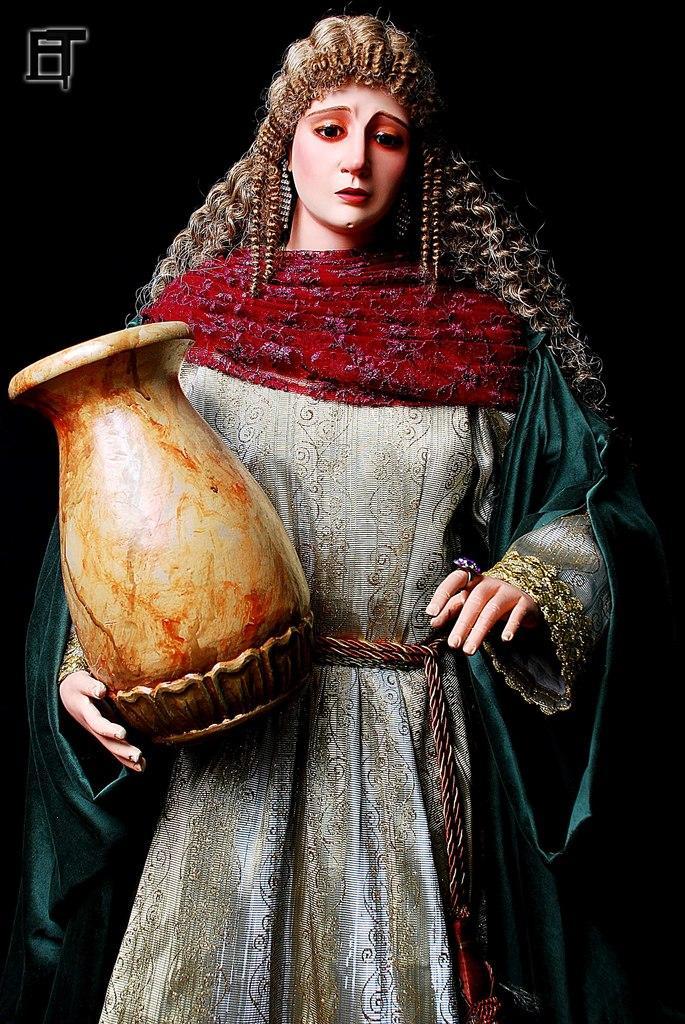How would you summarize this image in a sentence or two? In this picture we can see a woman, she is holding a pot and in the background we can see it is dark, in the top left we can see a logo on it. 